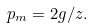<formula> <loc_0><loc_0><loc_500><loc_500>p _ { m } = 2 g / z .</formula> 